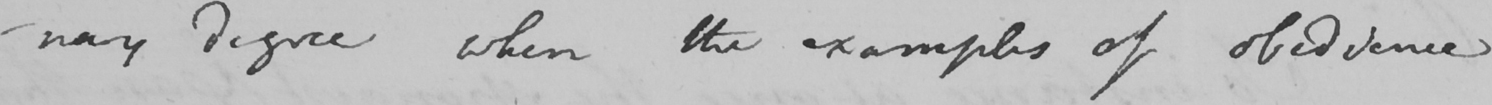What is written in this line of handwriting? -nary degree when the examples of obedience 